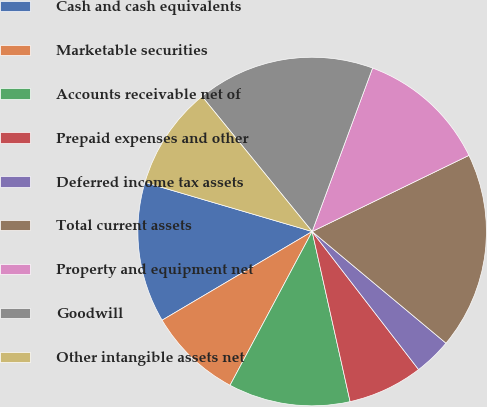Convert chart to OTSL. <chart><loc_0><loc_0><loc_500><loc_500><pie_chart><fcel>Cash and cash equivalents<fcel>Marketable securities<fcel>Accounts receivable net of<fcel>Prepaid expenses and other<fcel>Deferred income tax assets<fcel>Total current assets<fcel>Property and equipment net<fcel>Goodwill<fcel>Other intangible assets net<nl><fcel>13.04%<fcel>8.7%<fcel>11.3%<fcel>6.96%<fcel>3.48%<fcel>18.26%<fcel>12.17%<fcel>16.52%<fcel>9.57%<nl></chart> 